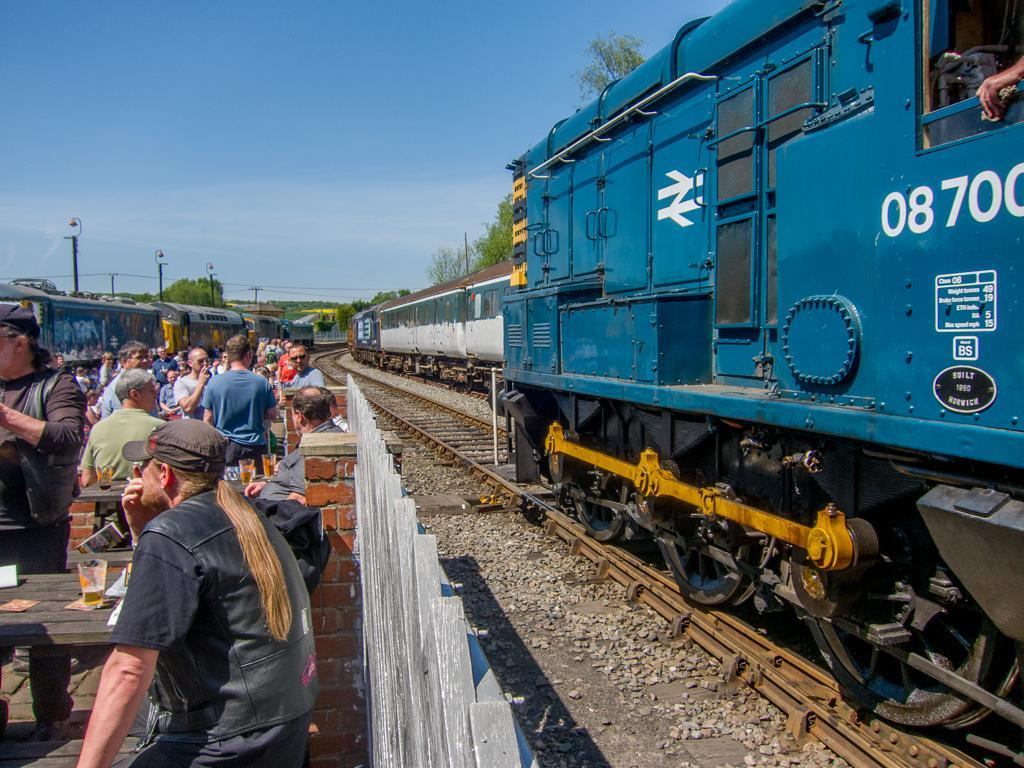<image>
Give a short and clear explanation of the subsequent image. People eating in front of a blue train with the numbers 08700 on it. 